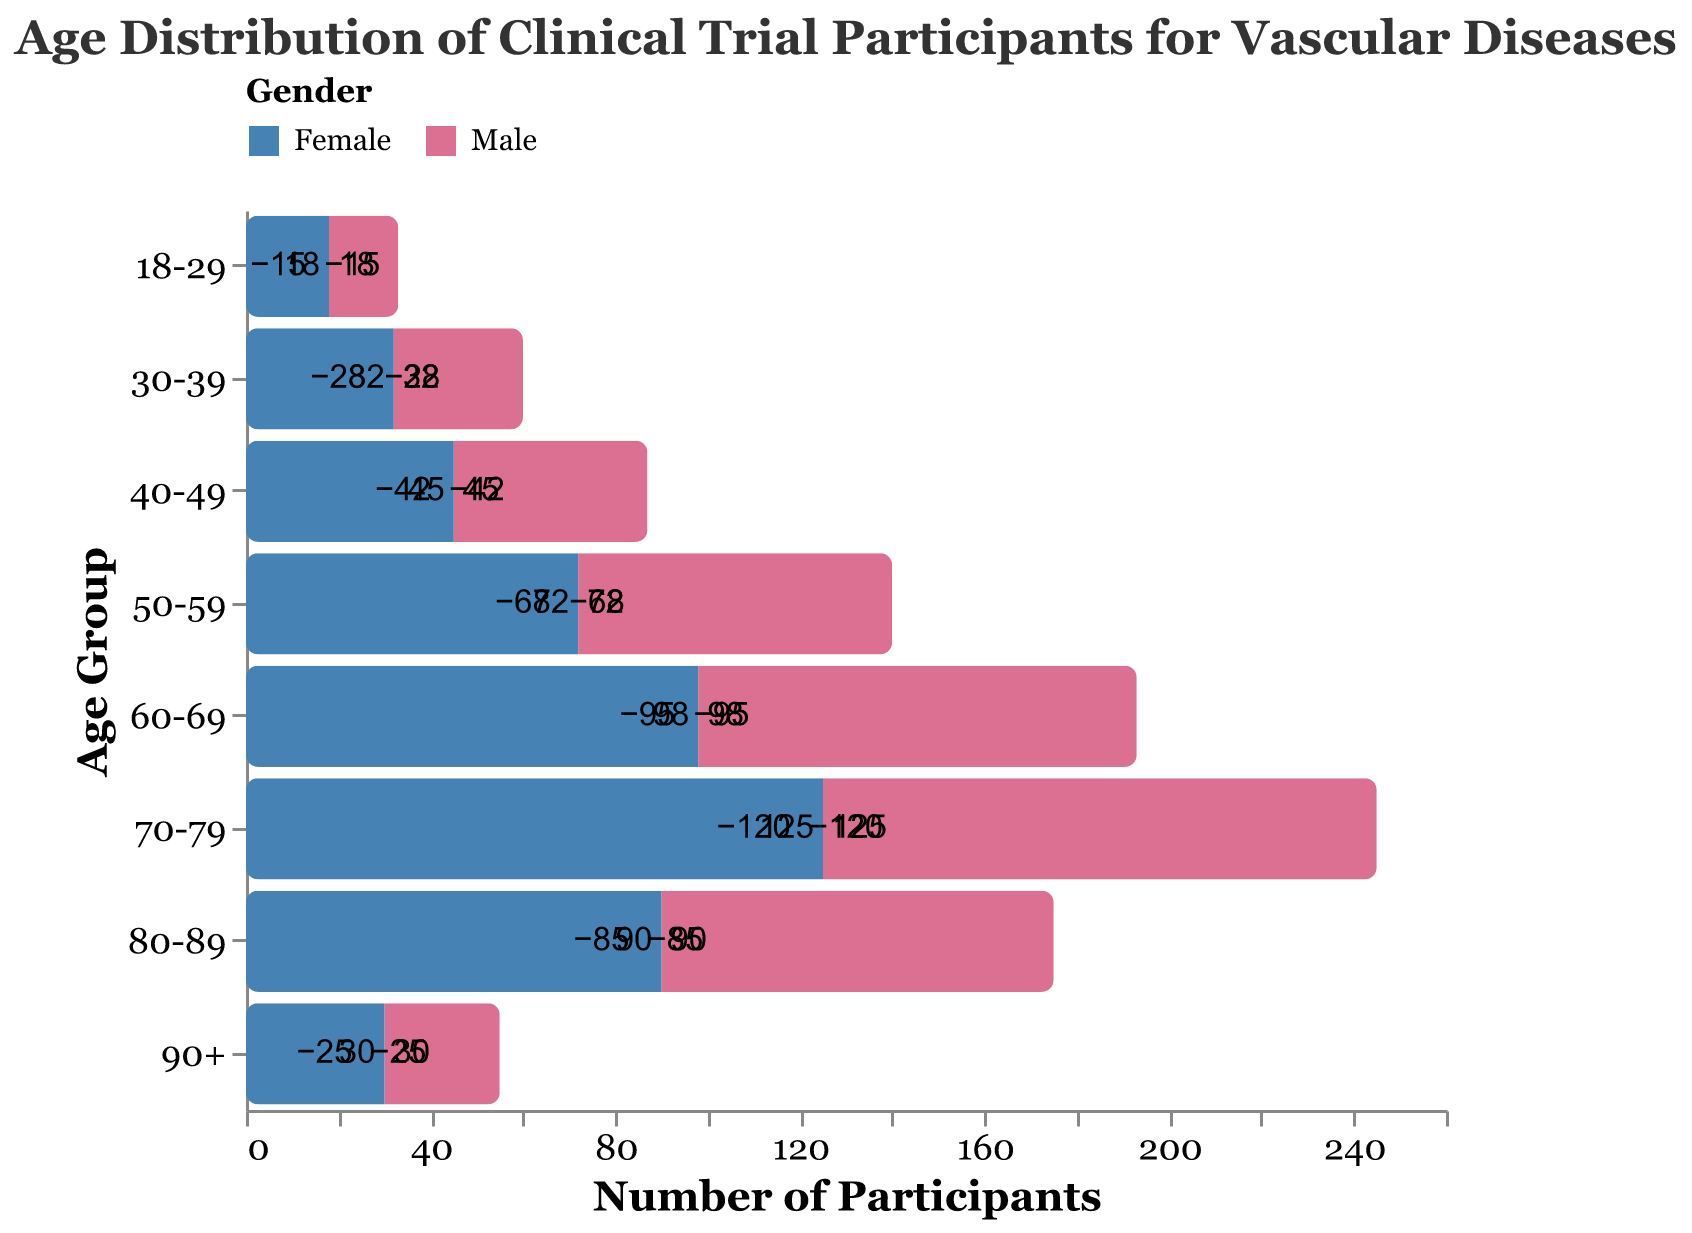What is the total number of male participants in the age group 50-59? The figure shows the number of male participants as -68 in the age group 50-59. Since this is already provided in the data, we can directly use this value.
Answer: 68 Which age group has the highest number of female participants? By examining the values for female participants, the age group 70-79 has the highest number of females with 125 participants.
Answer: 70-79 How does the number of male participants in the age group 70-79 compare to those in the age group 60-69? The figure shows 120 male participants in the age group 70-79 and 95 male participants in the age group 60-69. Hence, 70-79 has more male participants.
Answer: 70-79 What is the total number of participants in the age group 18-29? Adding the male and female participants in the age group 18-29, we get 15 (male) + 18 (female) = 33.
Answer: 33 Which gender has more participants in the age group 90+? According to the plot, there are 30 female participants and 25 male participants in the age group 90+. So, females have more participants.
Answer: Female How many more female participants are there in the age group 40-49 compared to male participants? Female participants in 40-49 are 45 and male participants are 42. The difference is 45 - 42 = 3.
Answer: 3 What is the age group with the minimum total number of participants? By summing up the male and female participants for each age group and comparing them, the age group 18-29 has the minimum total with 15 + 18 = 33 participants.
Answer: 18-29 What is the total number of participants aged 60 and above? Summing the participants aged 60 and above: 60-69: 95 (male) + 98 (female), 70-79: 120 (male) + 125 (female), 80-89: 85 (male) + 90 (female), 90+: 25 (male) + 30 (female). Total = 623.
Answer: 623 Which age group has the closest number of male and female participants? Comparing the difference between male and female participants in each age group, the age group 40-49 has the closest with a difference of 3 (45 female - 42 male).
Answer: 40-49 